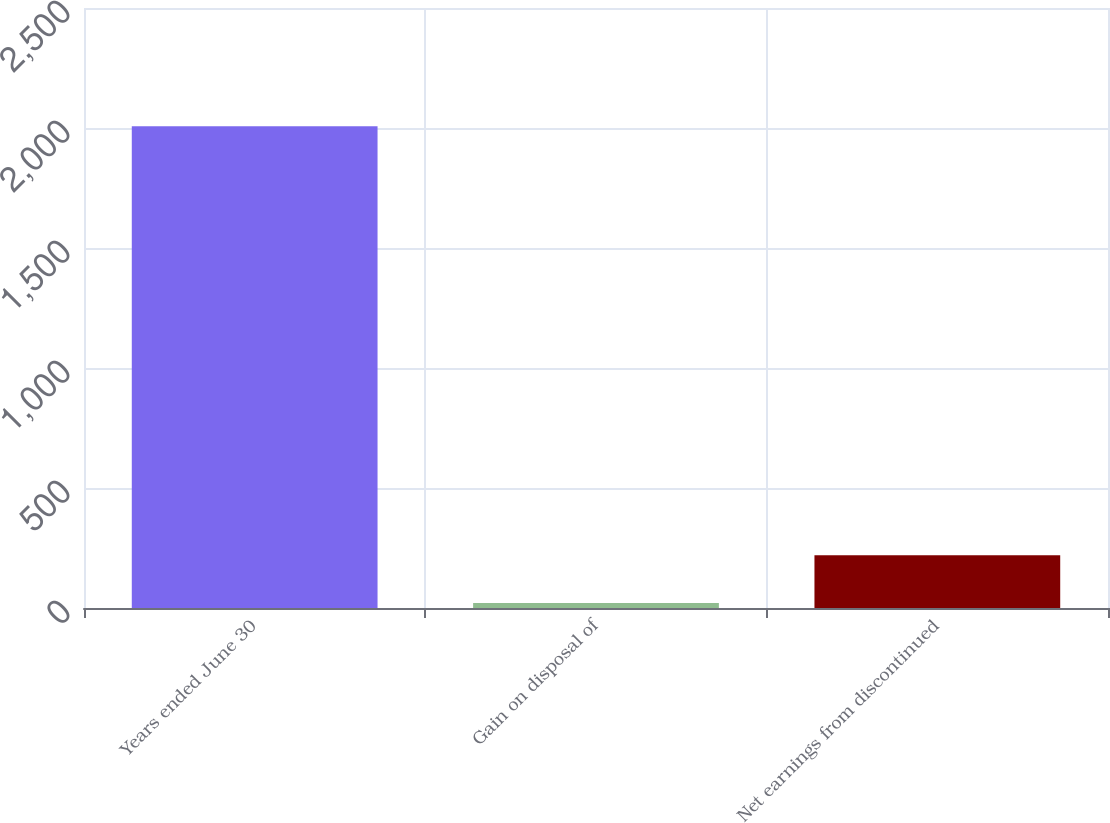Convert chart to OTSL. <chart><loc_0><loc_0><loc_500><loc_500><bar_chart><fcel>Years ended June 30<fcel>Gain on disposal of<fcel>Net earnings from discontinued<nl><fcel>2007<fcel>20.9<fcel>219.51<nl></chart> 